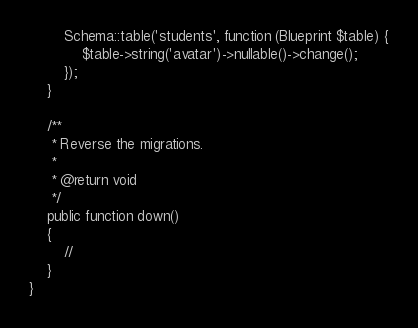<code> <loc_0><loc_0><loc_500><loc_500><_PHP_>        Schema::table('students', function (Blueprint $table) {
            $table->string('avatar')->nullable()->change();
        });
    }

    /**
     * Reverse the migrations.
     *
     * @return void
     */
    public function down()
    {
        //
    }
}
</code> 